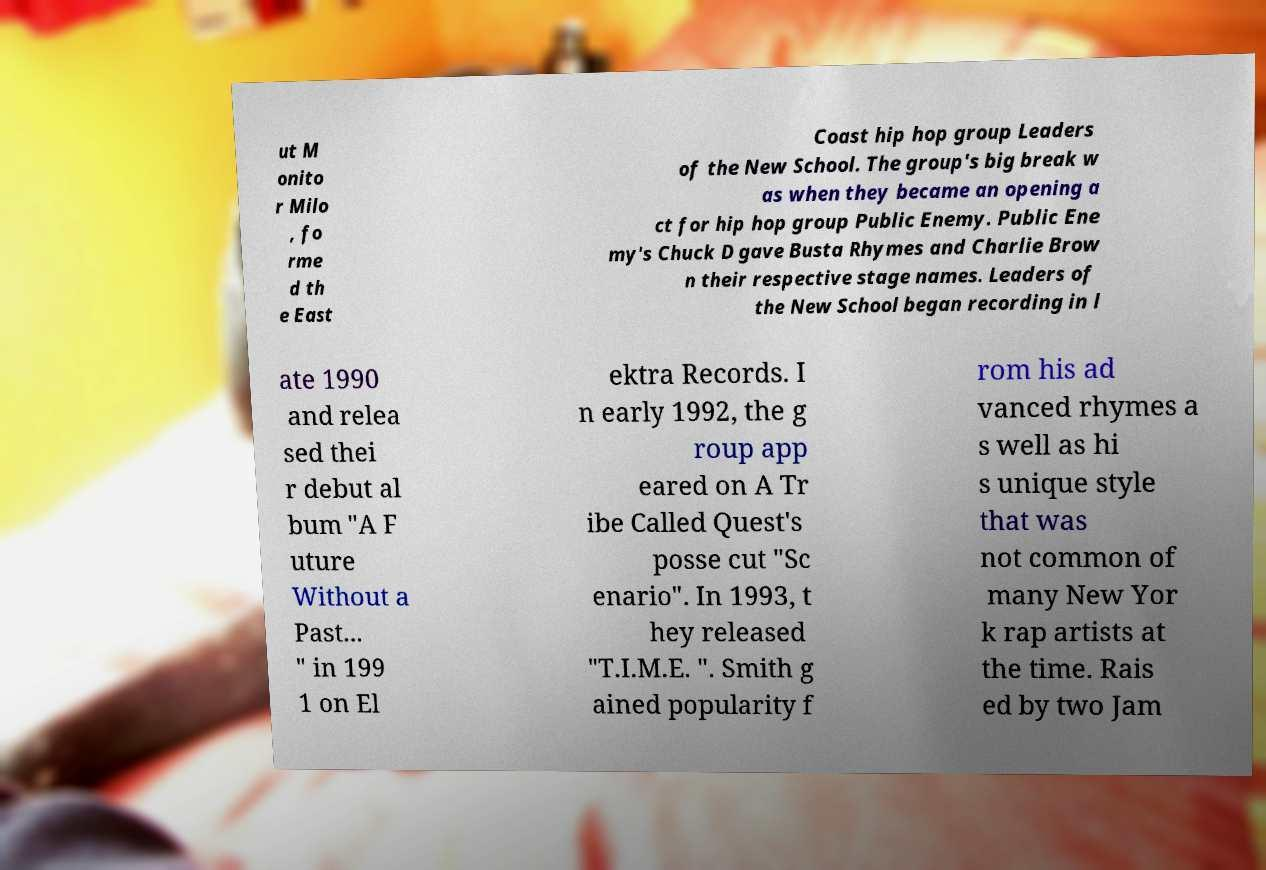Could you assist in decoding the text presented in this image and type it out clearly? ut M onito r Milo , fo rme d th e East Coast hip hop group Leaders of the New School. The group's big break w as when they became an opening a ct for hip hop group Public Enemy. Public Ene my's Chuck D gave Busta Rhymes and Charlie Brow n their respective stage names. Leaders of the New School began recording in l ate 1990 and relea sed thei r debut al bum "A F uture Without a Past... " in 199 1 on El ektra Records. I n early 1992, the g roup app eared on A Tr ibe Called Quest's posse cut "Sc enario". In 1993, t hey released "T.I.M.E. ". Smith g ained popularity f rom his ad vanced rhymes a s well as hi s unique style that was not common of many New Yor k rap artists at the time. Rais ed by two Jam 